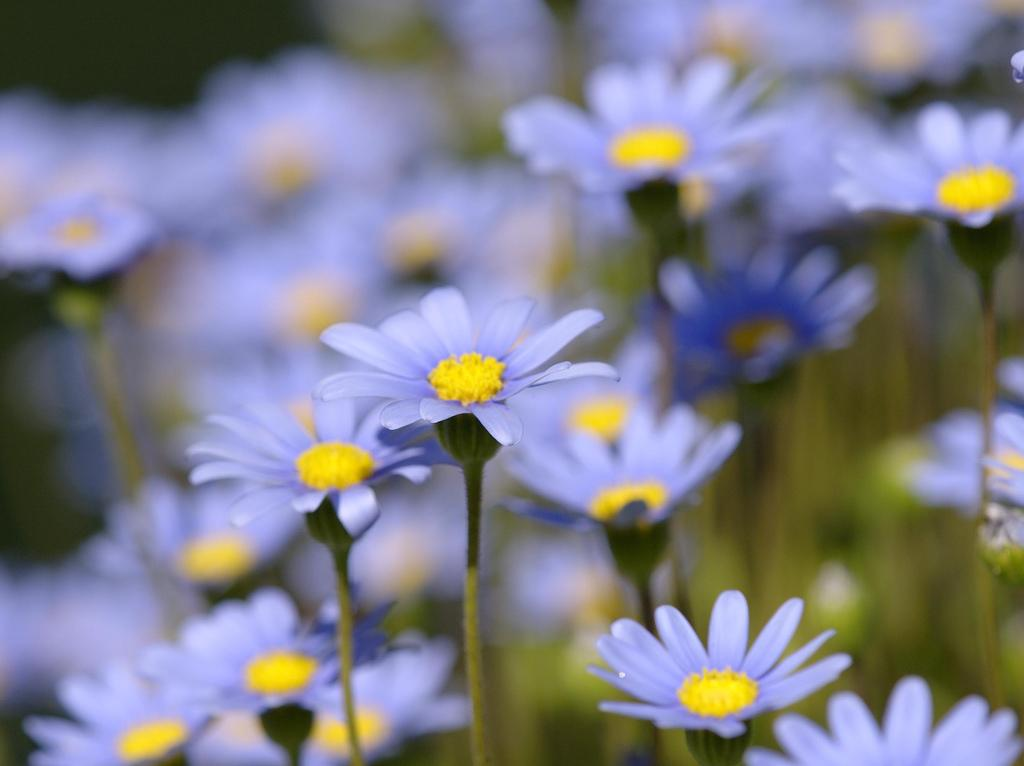What color are the flowers in the image? The flowers in the image are blue. What part of the flowers can be seen in the image? The flowers have stems and a yellow middle part. How would you describe the background of the image? The background of the image is blurred. Can you tell me how many people are holding the flowers in the image? There are no people present in the image; it only features flowers. 